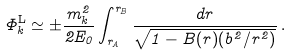Convert formula to latex. <formula><loc_0><loc_0><loc_500><loc_500>\Phi _ { k } ^ { \mathrm L } \simeq \pm \frac { m _ { k } ^ { 2 } } { 2 E _ { 0 } } \int _ { r _ { A } } ^ { r _ { B } } \frac { d r } { \sqrt { 1 - B ( r ) ( b ^ { 2 } / r ^ { 2 } ) } } \, .</formula> 